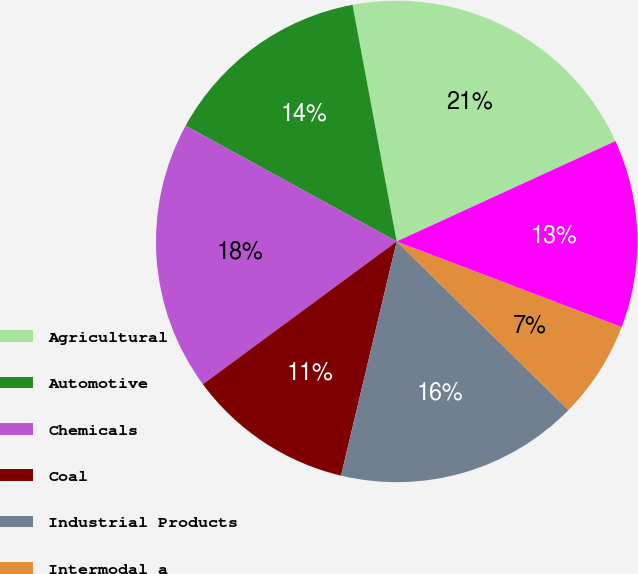Convert chart to OTSL. <chart><loc_0><loc_0><loc_500><loc_500><pie_chart><fcel>Agricultural<fcel>Automotive<fcel>Chemicals<fcel>Coal<fcel>Industrial Products<fcel>Intermodal a<fcel>Average<nl><fcel>21.09%<fcel>14.08%<fcel>18.09%<fcel>11.18%<fcel>16.36%<fcel>6.57%<fcel>12.63%<nl></chart> 